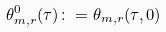Convert formula to latex. <formula><loc_0><loc_0><loc_500><loc_500>\theta _ { m , r } ^ { 0 } ( \tau ) \colon = \theta _ { m , r } ( \tau , 0 )</formula> 